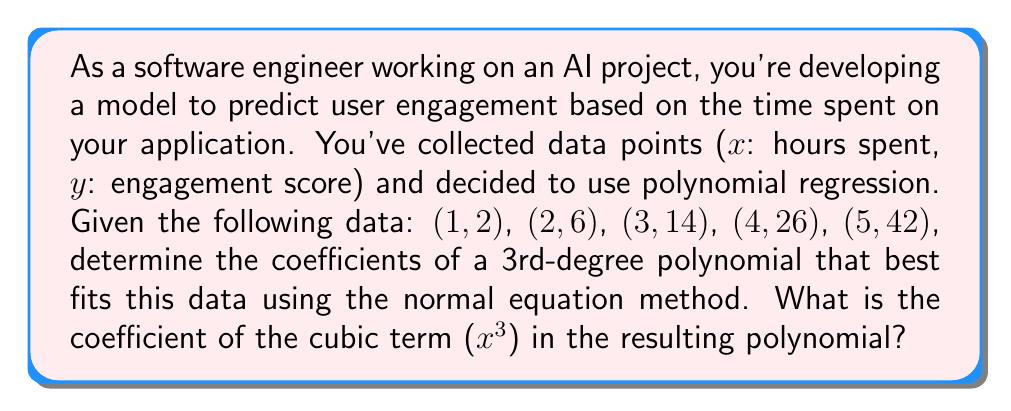Give your solution to this math problem. Let's approach this step-by-step:

1) For a 3rd-degree polynomial, we have the form:
   $$ y = a_0 + a_1x + a_2x^2 + a_3x^3 $$

2) We need to set up the normal equation:
   $$ (X^T X) \hat{\beta} = X^T y $$
   where X is the design matrix and y is the vector of engagement scores.

3) Let's construct the design matrix X:
   $$ X = \begin{bmatrix}
   1 & 1 & 1^2 & 1^3 \\
   1 & 2 & 2^2 & 2^3 \\
   1 & 3 & 3^2 & 3^3 \\
   1 & 4 & 4^2 & 4^3 \\
   1 & 5 & 5^2 & 5^3
   \end{bmatrix} $$

4) And the y vector:
   $$ y = \begin{bmatrix} 2 \\ 6 \\ 14 \\ 26 \\ 42 \end{bmatrix} $$

5) Now we need to calculate $X^T X$ and $X^T y$:
   
   $X^T X = \begin{bmatrix}
   5 & 15 & 55 & 225 \\
   15 & 55 & 225 & 979 \\
   55 & 225 & 979 & 4425 \\
   225 & 979 & 4425 & 20615
   \end{bmatrix}$

   $X^T y = \begin{bmatrix} 90 \\ 380 \\ 1740 \\ 8180 \end{bmatrix}$

6) Solve the equation $(X^T X) \hat{\beta} = X^T y$ for $\hat{\beta}$. This can be done using matrix inversion:
   $$ \hat{\beta} = (X^T X)^{-1} X^T y $$

7) Using a computer algebra system or calculator to perform this calculation, we get:
   $$ \hat{\beta} = \begin{bmatrix} -2 \\ 1 \\ -1 \\ 1 \end{bmatrix} $$

8) This means our polynomial is:
   $$ y = -2 + x - x^2 + x^3 $$

9) The coefficient of the cubic term (x³) is 1.
Answer: 1 